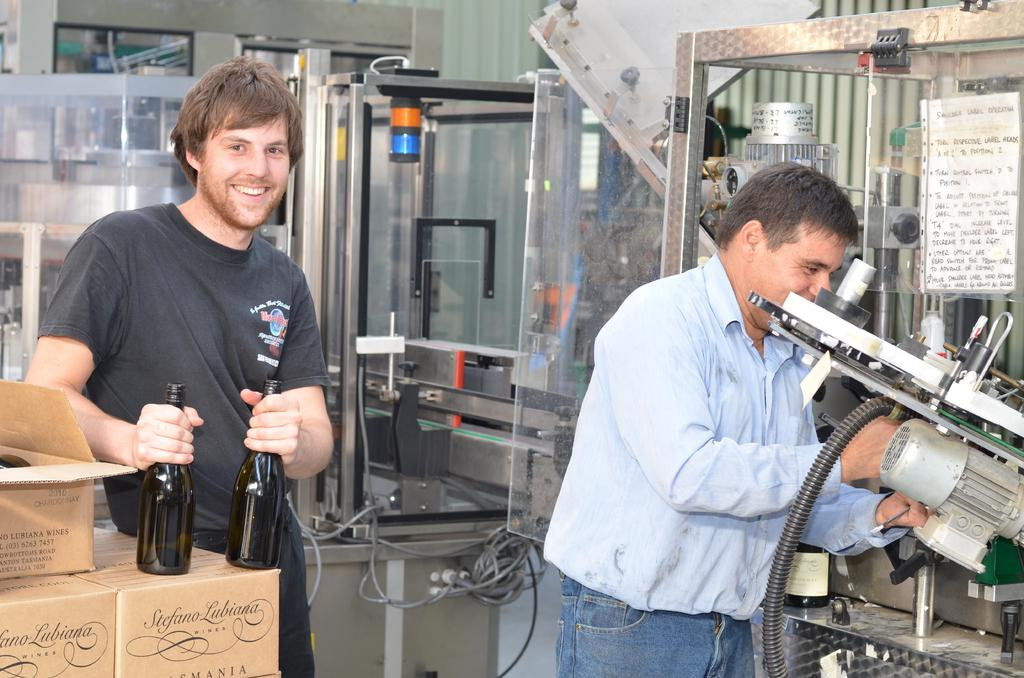Who is the main subject in the image? There is a guy in the image. What is the guy holding in the image? The guy is holding two glass bottles. What is the other person doing in the image? The other person is operating a machine. What can be seen in the background of the image? There are many machines in the background of the image. What type of rhythm is the manager tapping on the button in the image? There is no manager or button present in the image. 